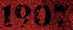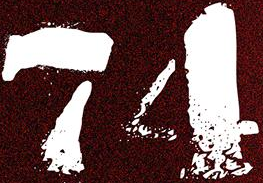Read the text content from these images in order, separated by a semicolon. 1907; 74 